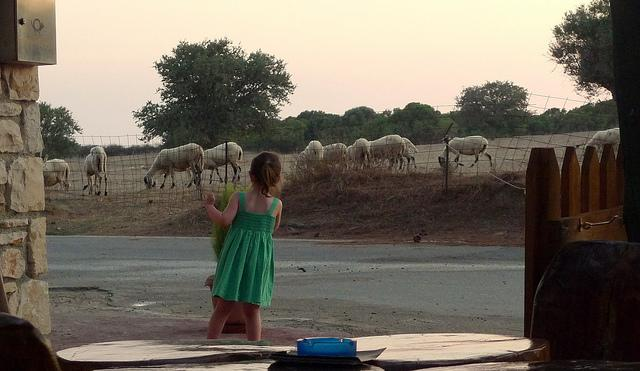What does the girl want to pet?

Choices:
A) foxes
B) snakes
C) sheep
D) chickens sheep 